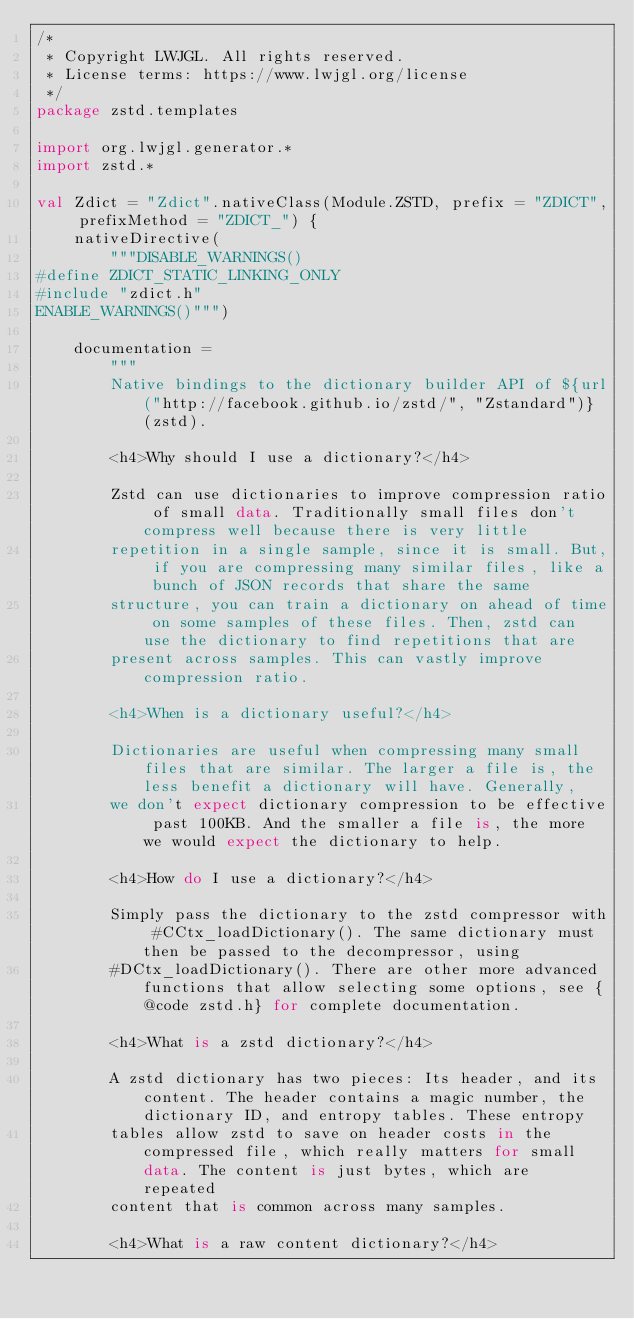<code> <loc_0><loc_0><loc_500><loc_500><_Kotlin_>/*
 * Copyright LWJGL. All rights reserved.
 * License terms: https://www.lwjgl.org/license
 */
package zstd.templates

import org.lwjgl.generator.*
import zstd.*

val Zdict = "Zdict".nativeClass(Module.ZSTD, prefix = "ZDICT", prefixMethod = "ZDICT_") {
    nativeDirective(
        """DISABLE_WARNINGS()
#define ZDICT_STATIC_LINKING_ONLY
#include "zdict.h"
ENABLE_WARNINGS()""")

    documentation =
        """
        Native bindings to the dictionary builder API of ${url("http://facebook.github.io/zstd/", "Zstandard")} (zstd).

        <h4>Why should I use a dictionary?</h4>

        Zstd can use dictionaries to improve compression ratio of small data. Traditionally small files don't compress well because there is very little
        repetition in a single sample, since it is small. But, if you are compressing many similar files, like a bunch of JSON records that share the same
        structure, you can train a dictionary on ahead of time on some samples of these files. Then, zstd can use the dictionary to find repetitions that are
        present across samples. This can vastly improve compression ratio.
 
        <h4>When is a dictionary useful?</h4>

        Dictionaries are useful when compressing many small files that are similar. The larger a file is, the less benefit a dictionary will have. Generally,
        we don't expect dictionary compression to be effective past 100KB. And the smaller a file is, the more we would expect the dictionary to help.
 
        <h4>How do I use a dictionary?</h4>
  
        Simply pass the dictionary to the zstd compressor with #CCtx_loadDictionary(). The same dictionary must then be passed to the decompressor, using
        #DCtx_loadDictionary(). There are other more advanced functions that allow selecting some options, see {@code zstd.h} for complete documentation.
 
        <h4>What is a zstd dictionary?</h4>

        A zstd dictionary has two pieces: Its header, and its content. The header contains a magic number, the dictionary ID, and entropy tables. These entropy
        tables allow zstd to save on header costs in the compressed file, which really matters for small data. The content is just bytes, which are repeated
        content that is common across many samples.
 
        <h4>What is a raw content dictionary?</h4>
  </code> 